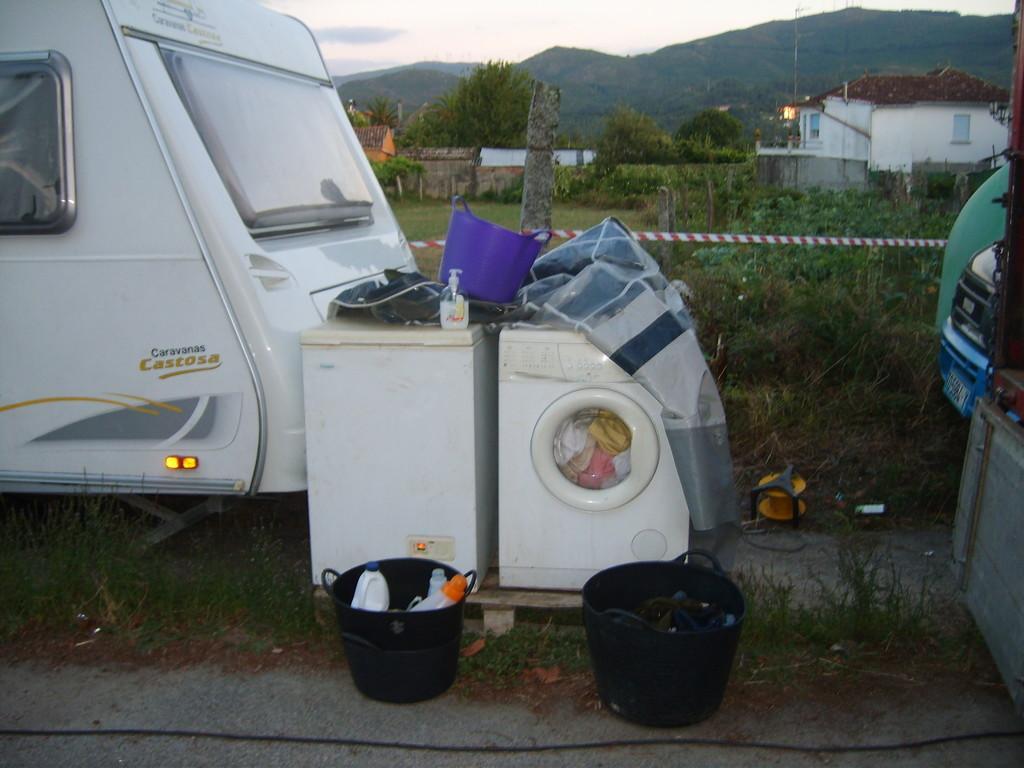How would you summarize this image in a sentence or two? Here we can see vehicles, washing machine, buckets, bottles, basket, and clothes. This is grass and there are plants. In the background we can see houses, trees, poles, and sky. 